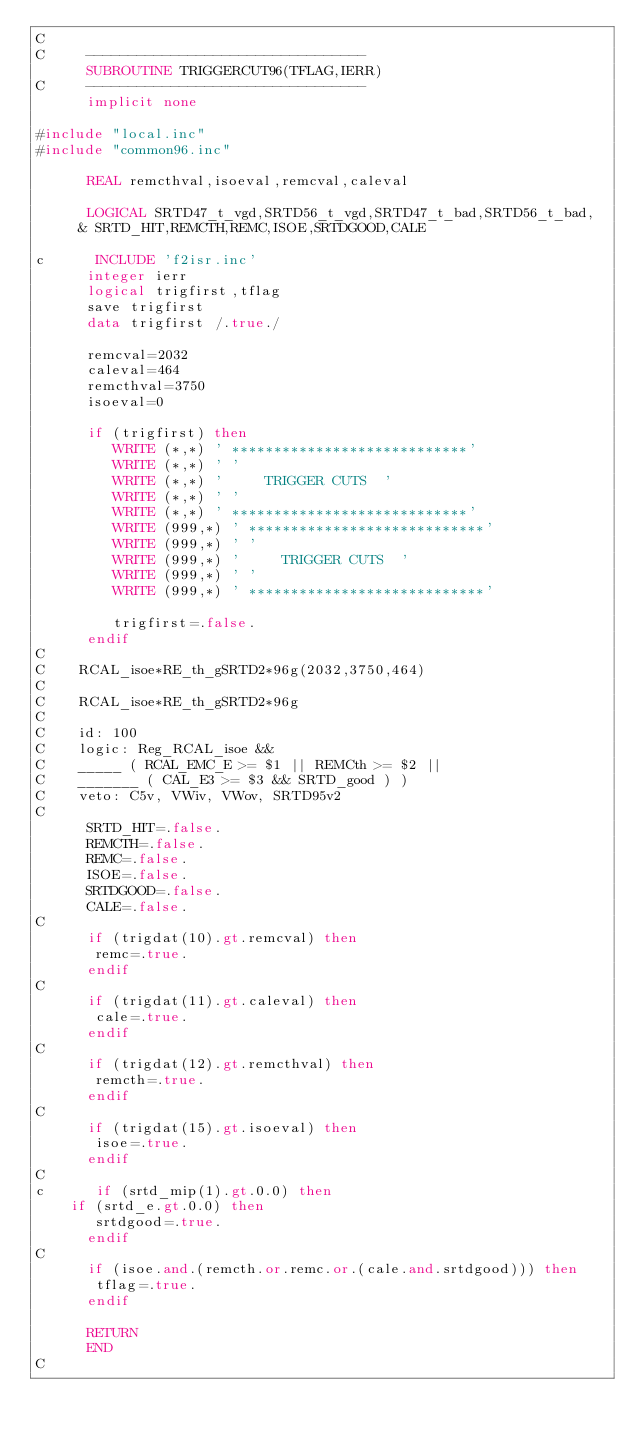Convert code to text. <code><loc_0><loc_0><loc_500><loc_500><_FORTRAN_>C
C     ---------------------------------
      SUBROUTINE TRIGGERCUT96(TFLAG,IERR)
C     ---------------------------------
      implicit none

#include "local.inc"
#include "common96.inc"

      REAL remcthval,isoeval,remcval,caleval

      LOGICAL SRTD47_t_vgd,SRTD56_t_vgd,SRTD47_t_bad,SRTD56_t_bad,
     & SRTD_HIT,REMCTH,REMC,ISOE,SRTDGOOD,CALE

c      INCLUDE 'f2isr.inc'
      integer ierr
      logical trigfirst,tflag
      save trigfirst
      data trigfirst /.true./

      remcval=2032
      caleval=464
      remcthval=3750
      isoeval=0

      if (trigfirst) then
         WRITE (*,*) ' ****************************'
         WRITE (*,*) ' '
         WRITE (*,*) '     TRIGGER CUTS  '
         WRITE (*,*) ' '
         WRITE (*,*) ' ****************************'
         WRITE (999,*) ' ****************************'
         WRITE (999,*) ' '
         WRITE (999,*) '     TRIGGER CUTS  '
         WRITE (999,*) ' '
         WRITE (999,*) ' ****************************'

         trigfirst=.false.
      endif
C
C    RCAL_isoe*RE_th_gSRTD2*96g(2032,3750,464)
C
C    RCAL_isoe*RE_th_gSRTD2*96g
C
C    id: 100 
C    logic: Reg_RCAL_isoe &&
C    _____ ( RCAL_EMC_E >= $1 || REMCth >= $2 ||
C    _______ ( CAL_E3 >= $3 && SRTD_good ) ) 
C    veto: C5v, VWiv, VWov, SRTD95v2 
C
      SRTD_HIT=.false.
      REMCTH=.false.
      REMC=.false.
      ISOE=.false.
      SRTDGOOD=.false.
      CALE=.false.
C
      if (trigdat(10).gt.remcval) then
       remc=.true.
      endif
C
      if (trigdat(11).gt.caleval) then
       cale=.true.
      endif
C
      if (trigdat(12).gt.remcthval) then
       remcth=.true.
      endif
C
      if (trigdat(15).gt.isoeval) then
       isoe=.true.
      endif
C
c      if (srtd_mip(1).gt.0.0) then
	if (srtd_e.gt.0.0) then
       srtdgood=.true.
      endif
C
      if (isoe.and.(remcth.or.remc.or.(cale.and.srtdgood))) then
       tflag=.true.
      endif

      RETURN
      END
C



</code> 